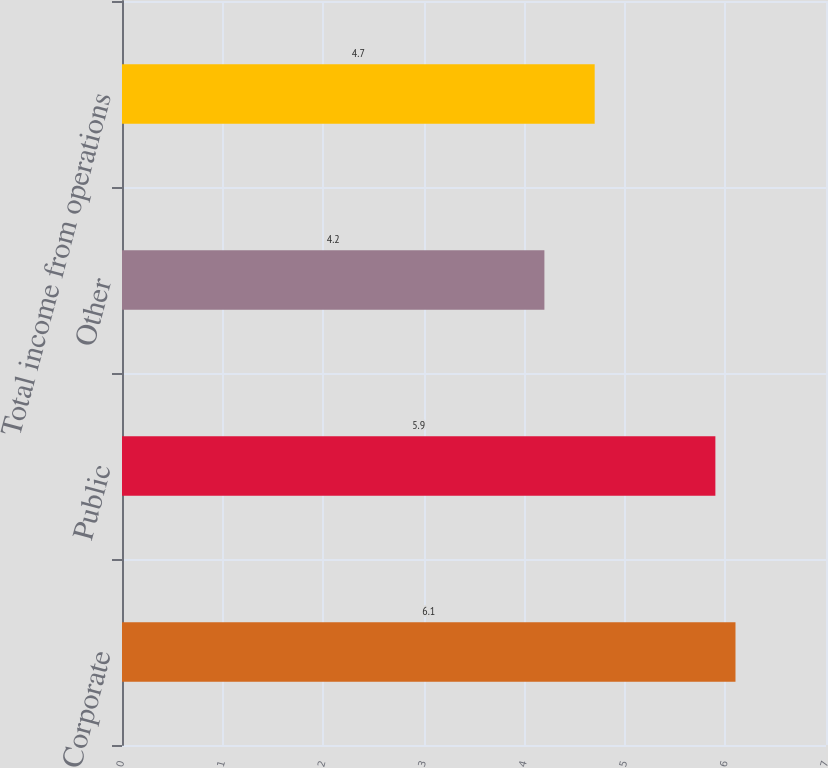Convert chart to OTSL. <chart><loc_0><loc_0><loc_500><loc_500><bar_chart><fcel>Corporate<fcel>Public<fcel>Other<fcel>Total income from operations<nl><fcel>6.1<fcel>5.9<fcel>4.2<fcel>4.7<nl></chart> 